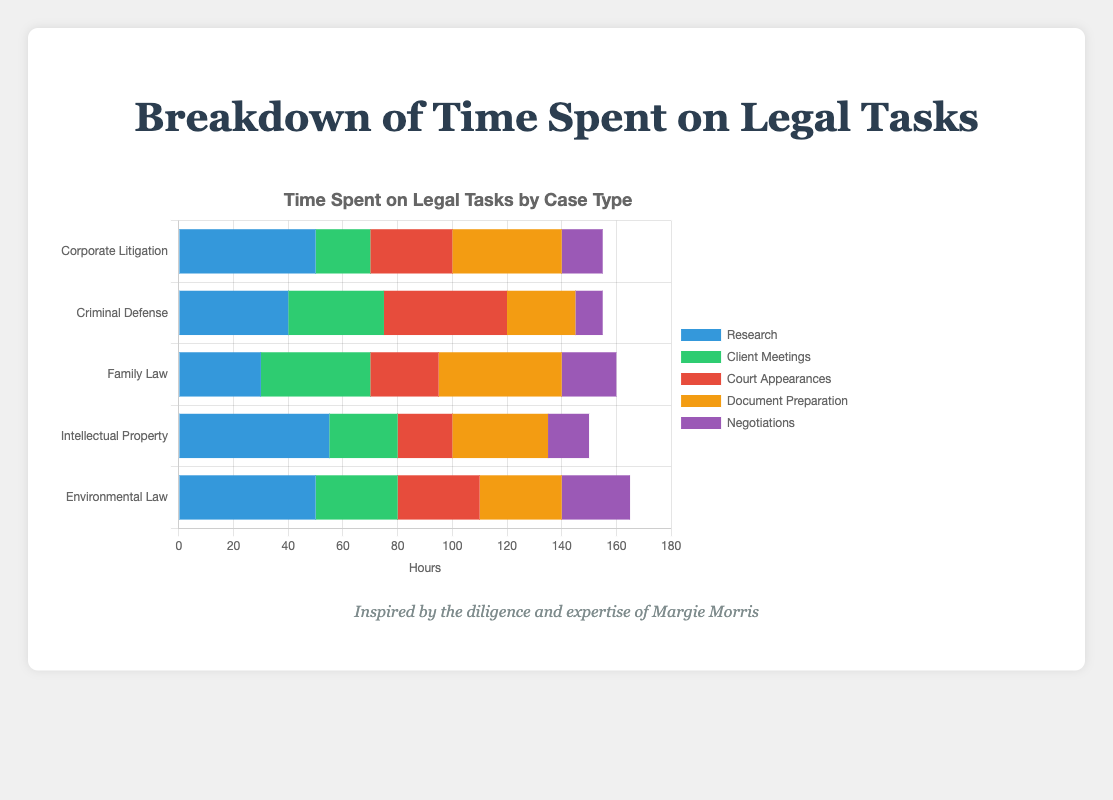Which case type has the highest time spent on Client Meetings? Compare the bar segment heights for "Client Meetings" across all case types; Family Law has the longest bar.
Answer: Family Law How much more time is roughly spent on Document Preparation in Family Law compared to Criminal Defense? Document Preparation time for Family Law is 45 hours, and for Criminal Defense, it is 25 hours. Calculate 45 - 25.
Answer: 20 hours For which tasks is the time spent greater in Environmental Law compared to Corporate Litigation? Compare the bar segments for both case types across each task. In Environmental Law, Research (50 vs. 50), Client Meetings (30 vs. 20), and Negotiations (25 vs. 15) have greater time spent.
Answer: Client Meetings, Negotiations Which task has the smallest total time spent across all case types? Sum the time spent on each task across all case types: Research (225), Client Meetings (150), Court Appearances (150), Document Preparation (175), Negotiations (85).
Answer: Negotiations What is the total time spent on court appearances for Criminal Defense and Intellectual Property combined? Sum the hours spent on court appearances for both case types: 45 (Criminal Defense) + 20 (Intellectual Property).
Answer: 65 hours What color represents the task with the lowest time spent in Intellectual Property? Look for the smallest bar segment in Intellectual Property, which is Court Appearances, represented by red.
Answer: Red Is there a case type where the time spent on research is more than twice the time spent on court appearances? Check if the length of the "Research" bar segment is more than twice the length of the "Court Appearances" bar segment for any case type (e.g., Intellectual Property: 55 vs. 20)
Answer: Yes What is the combined time spent on Research and Document Preparation in Corporate Litigation? Sum the hours spent on Research (50) and Document Preparation (40) in Corporate Litigation.
Answer: 90 hours Which two tasks together make up the most time in Family Law? Compare the sum of hours for each pair of tasks in Family Law, and Research (30) + Document Preparation (45) = 75 hours, total the highest.
Answer: Research and Document Preparation How does the time spent on Negotiations in Environmental Law compare to that in Criminal Defense? Compare the bar segments for Negotiations in Environmental Law (25) and Criminal Defense (10).
Answer: Greater in Environmental Law 